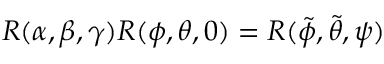<formula> <loc_0><loc_0><loc_500><loc_500>R ( \alpha , \beta , \gamma ) R ( \phi , \theta , 0 ) = R ( \tilde { \phi } , \tilde { \theta } , \psi )</formula> 